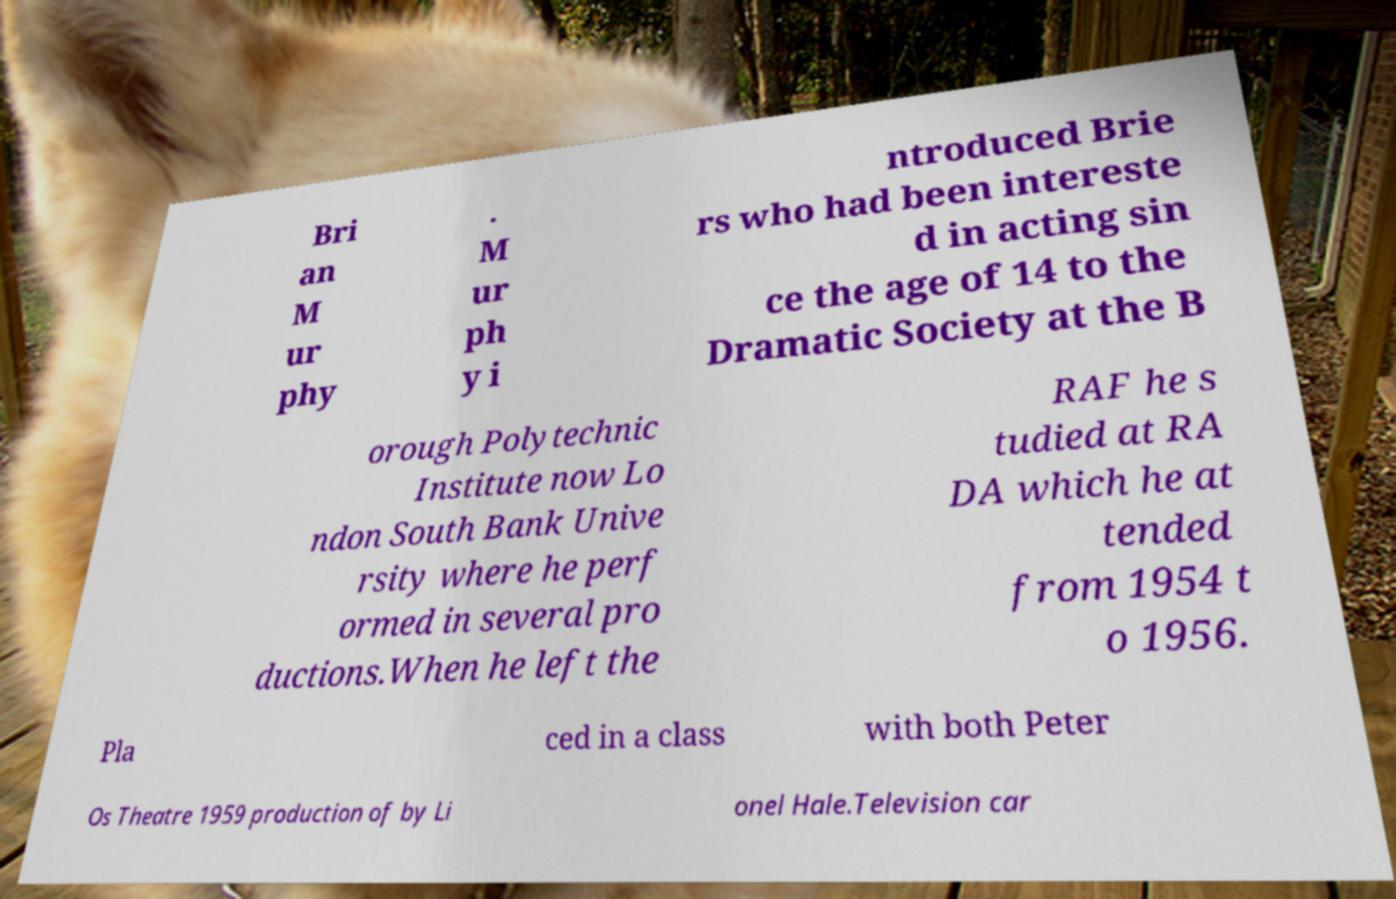What messages or text are displayed in this image? I need them in a readable, typed format. Bri an M ur phy . M ur ph y i ntroduced Brie rs who had been intereste d in acting sin ce the age of 14 to the Dramatic Society at the B orough Polytechnic Institute now Lo ndon South Bank Unive rsity where he perf ormed in several pro ductions.When he left the RAF he s tudied at RA DA which he at tended from 1954 t o 1956. Pla ced in a class with both Peter Os Theatre 1959 production of by Li onel Hale.Television car 